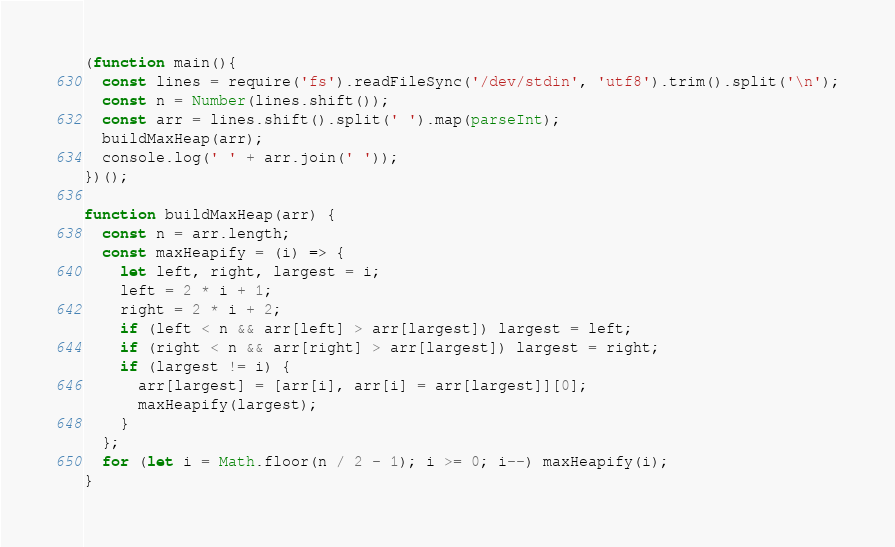<code> <loc_0><loc_0><loc_500><loc_500><_JavaScript_>(function main(){
  const lines = require('fs').readFileSync('/dev/stdin', 'utf8').trim().split('\n');
  const n = Number(lines.shift());
  const arr = lines.shift().split(' ').map(parseInt);
  buildMaxHeap(arr);
  console.log(' ' + arr.join(' '));
})();

function buildMaxHeap(arr) {
  const n = arr.length;
  const maxHeapify = (i) => {
    let left, right, largest = i;
    left = 2 * i + 1;
    right = 2 * i + 2;
    if (left < n && arr[left] > arr[largest]) largest = left;
    if (right < n && arr[right] > arr[largest]) largest = right;
    if (largest != i) {
      arr[largest] = [arr[i], arr[i] = arr[largest]][0];
      maxHeapify(largest);
    }
  };
  for (let i = Math.floor(n / 2 - 1); i >= 0; i--) maxHeapify(i);
}

</code> 